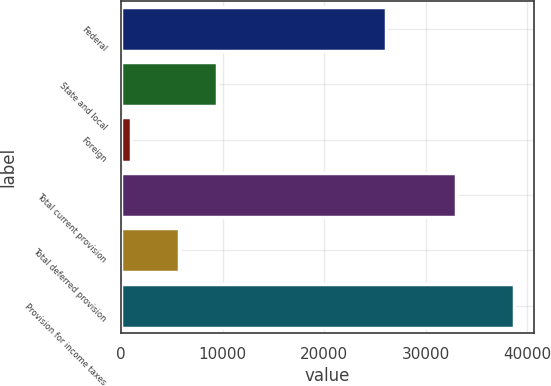<chart> <loc_0><loc_0><loc_500><loc_500><bar_chart><fcel>Federal<fcel>State and local<fcel>Foreign<fcel>Total current provision<fcel>Total deferred provision<fcel>Provision for income taxes<nl><fcel>26071<fcel>9444.3<fcel>1014<fcel>33043<fcel>5674<fcel>38717<nl></chart> 